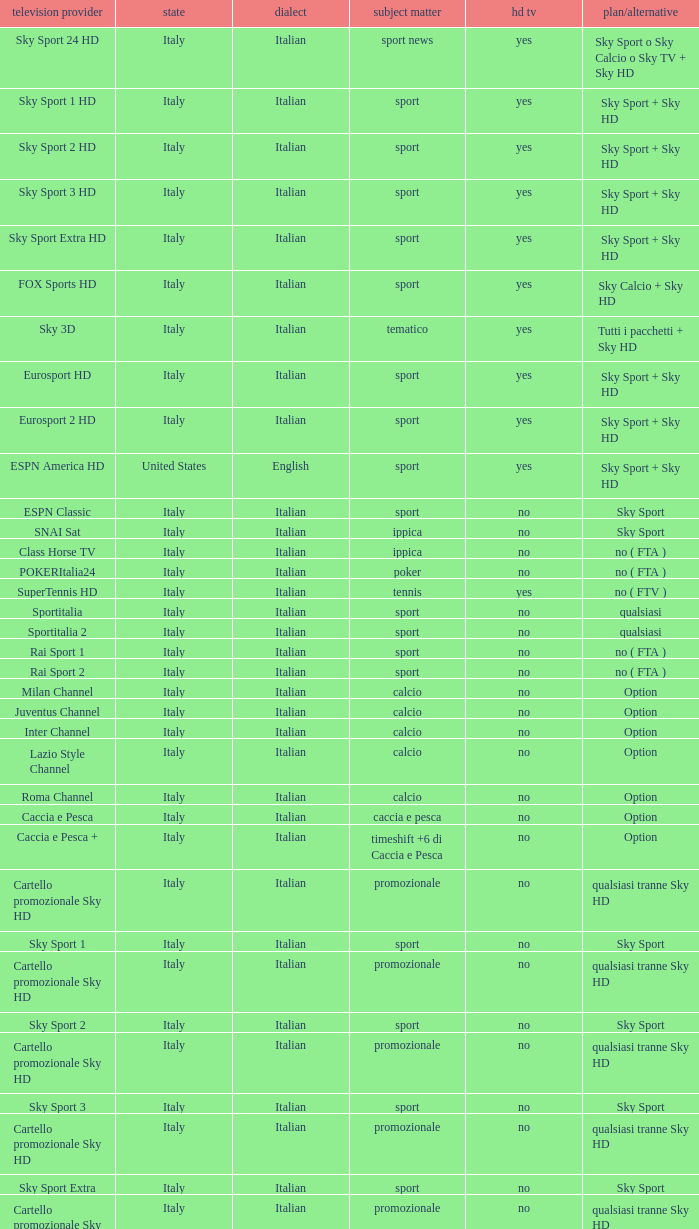What is Language, when Content is Sport, when HDTV is No, and when Television Service is ESPN America? Italian. 